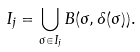Convert formula to latex. <formula><loc_0><loc_0><loc_500><loc_500>I _ { j } = \bigcup _ { \sigma \in I _ { j } } B ( \sigma , \delta ( \sigma ) ) .</formula> 